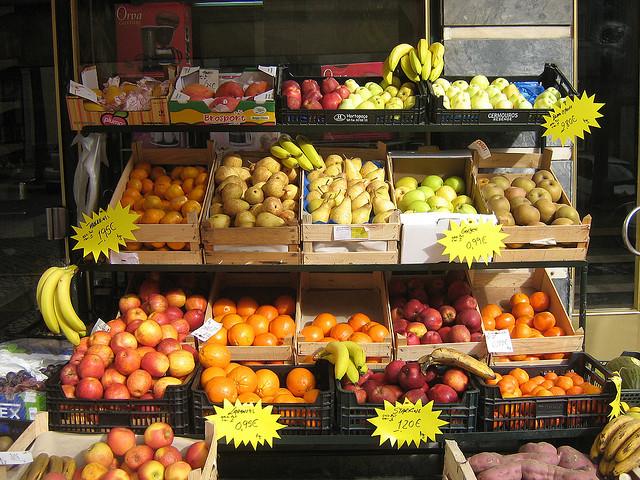What fruit doesn't have its own box?
Be succinct. Bananas. What fruit is hanging on the left side of the display?
Write a very short answer. Bananas. Which box has the most fruit?
Be succinct. Bottom left. 